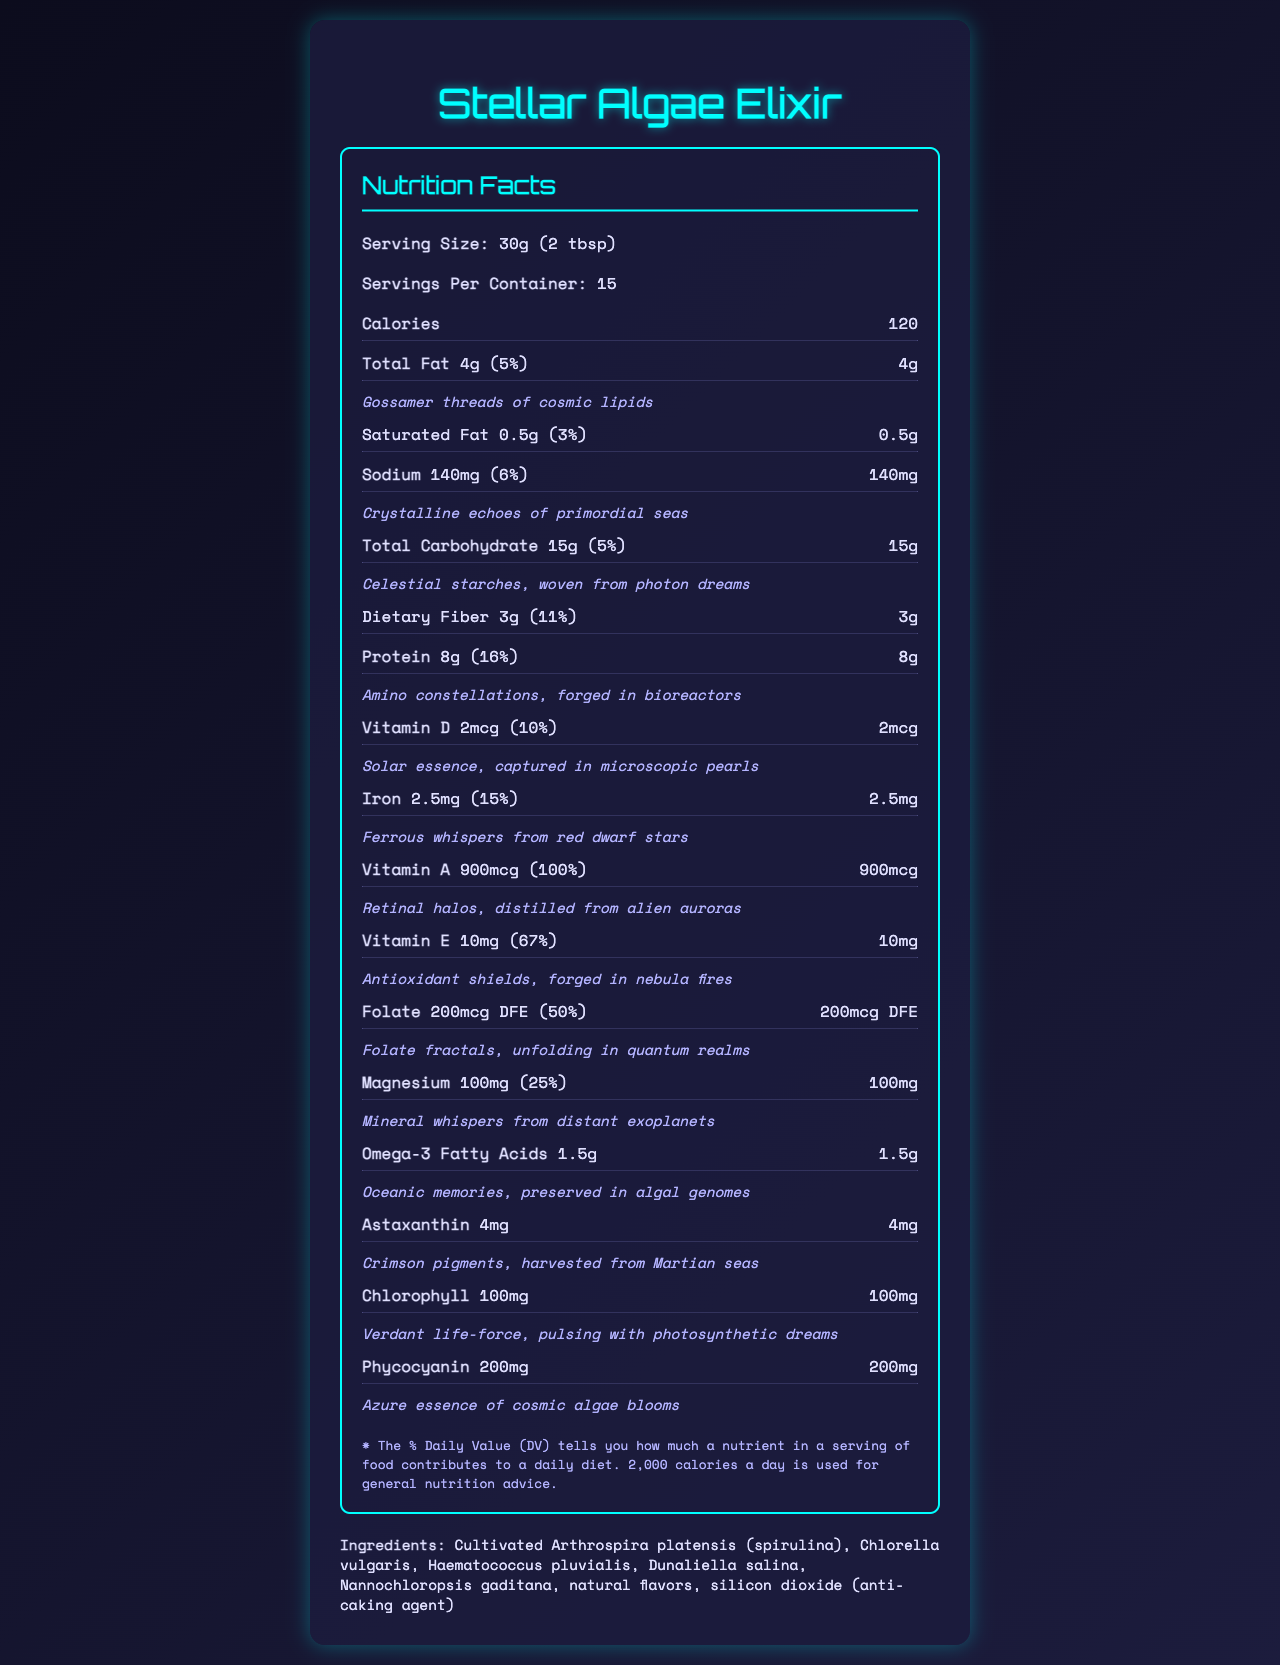what is the serving size of Stellar Algae Elixir? The serving size is mentioned at the beginning of the document with the label "Serving Size."
Answer: 30g (2 tbsp) how many calories are in each serving? The document lists calories as 120.
Answer: 120 calories what poetic description is given for the total fat? The poetic description appears just below the "Total Fat" section in the poetic style text.
Answer: Gossamer threads of cosmic lipids how much protein is in one serving? The protein amount is stated explicitly in both text and numerical form.
Answer: 8g how many servings are there per container? The number of servings per container is provided right after the serving size information.
Answer: 15 servings which nutrient has the highest daily value percentage? By comparing the daily value percentages listed for each nutrient, Vitamin A has the highest at 100%.
Answer: Vitamin A (100%) which of these nutrients has a poetic description? A. Dietary Fiber B. Calcium C. Potassium D. Magnesium Only Magnesium has a poetic description among the listed nutrients: "Mineral whispers from distant exoplanets."
Answer: D. Magnesium how much iron is in one serving? A. 2mg B. 2.5mg C. 2.5mcg D. 1.5mg The document lists iron at 2.5mg per serving.
Answer: B. 2.5mg does the product contain any cholesterol? The cholesterol amount is listed as 0mg, indicating there is no cholesterol.
Answer: No what poetic description is used for phycocyanin? The poetic description is found under the "Phycocyanin" section.
Answer: Azure essence of cosmic algae blooms does this product contain added sugars? The document shows that added sugars are 0g with a daily value of 0%.
Answer: No which vitamins are provided at 100% daily value in each serving? The document lists these vitamins with a 100% daily value.
Answer: Vitamin A, Vitamin B12, Biotin describe the main idea of the document. The document offers an overview of the Stellar Algae Elixir's nutrient composition, highlighting its health benefits through both scientific breakdowns and poetic language.
Answer: The document provides the nutritional information for Stellar Algae Elixir in a visually appealing and poetic format. It includes the serving size, servings per container, calories, and detailed information about fats, carbohydrates, proteins, vitamins, and minerals, along with their daily values and poetic descriptions. what are the ingredients of Stellar Algae Elixir? The ingredients list is located at the end of the document.
Answer: Cultivated Arthrospira platensis (spirulina), Chlorella vulgaris, Haematococcus pluvialis, Dunaliella salina, Nannochloropsis gaditana, natural flavors, silicon dioxide (anti-caking agent) what specific antioxidant is mentioned in the document? Astaxanthin is listed in the document with the poetic description "Crimson pigments, harvested from Martian seas."
Answer: Astaxanthin does the document provide information about fiber content? The dietary fiber content is listed in the nutrition facts section.
Answer: Yes is the product's taste or flavor profile described in the document? The document does not provide detailed taste or flavor descriptions aside from listing "natural flavors" in the ingredients.
Answer: Not enough information 